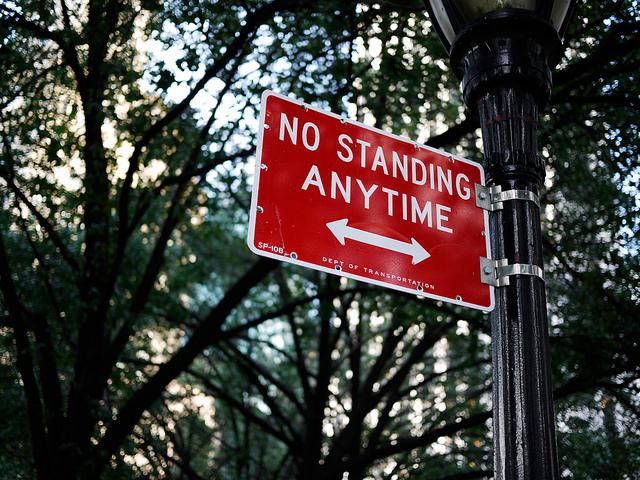What color is the sign?
Write a very short answer. Red. What type of a sign is that?
Answer briefly. No standing. What color is the post?
Keep it brief. Black. What color are the trees?
Quick response, please. Green. 